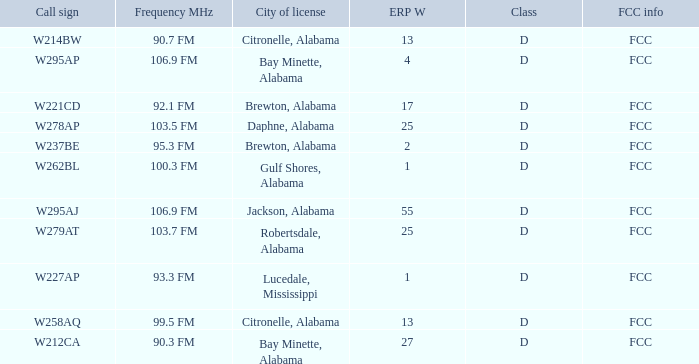Name the FCC info for call sign of w279at FCC. 